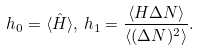<formula> <loc_0><loc_0><loc_500><loc_500>h _ { 0 } = \langle \hat { H } \rangle , \, h _ { 1 } = \frac { \langle H \Delta N \rangle } { \langle ( \Delta N ) ^ { 2 } \rangle } .</formula> 